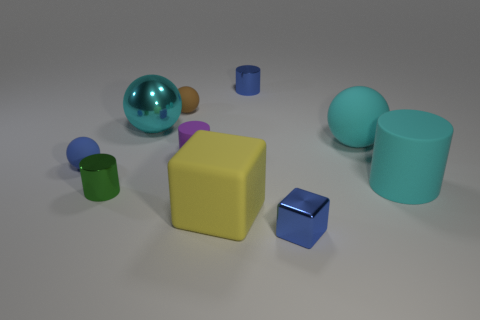Subtract 1 spheres. How many spheres are left? 3 Subtract all spheres. How many objects are left? 6 Add 8 cyan matte things. How many cyan matte things are left? 10 Add 7 cyan shiny objects. How many cyan shiny objects exist? 8 Subtract 0 gray cylinders. How many objects are left? 10 Subtract all small brown shiny cylinders. Subtract all small brown things. How many objects are left? 9 